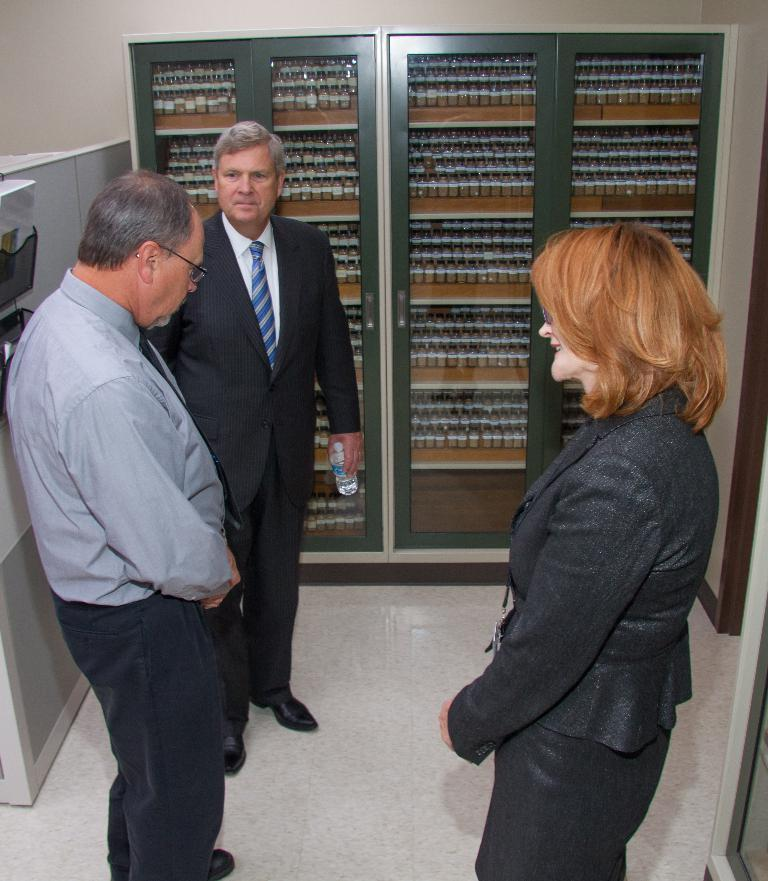How many people are in the image? There are two men and a woman in the image. What are the individuals in the image doing? They appear to be engaged in conversation. What can be observed about the individuals' physical state? They are standing. What are the individuals wearing? They are wearing clothes. What type of surface is visible in the image? There is a floor visible in the image. What type of furniture can be seen in the image? There are cupboards in the image. What is the background of the image composed of? There is a wall in the image. What type of glue is being used by the individuals in the image? There is no glue present in the image; the individuals are engaged in conversation. What new idea is being shared by the individuals in the image? The image does not provide information about the content of the conversation, so we cannot determine if a new idea is idea is being shared. 